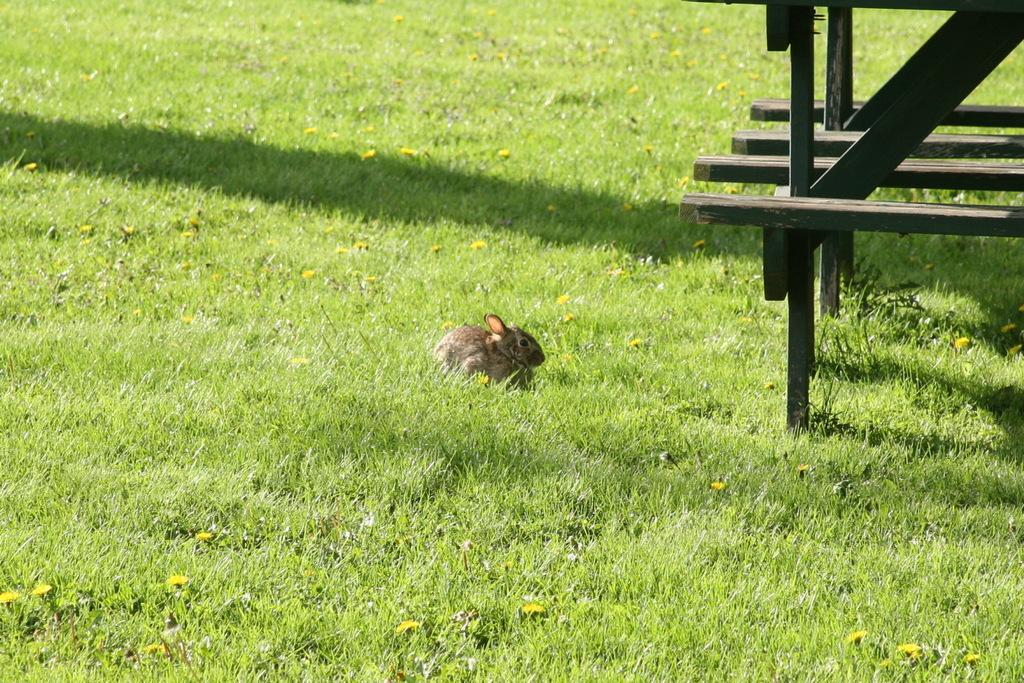What type of animal is in the image? The type of animal cannot be determined from the provided facts. What is the natural environment depicted in the image? The natural environment includes grass and flowers. What objects are on the right side of the image? There are wooden rods on the right side of the image. What type of soup is being served in the image? There is no soup present in the image. What type of test is being conducted in the image? There is no test being conducted in the image. 